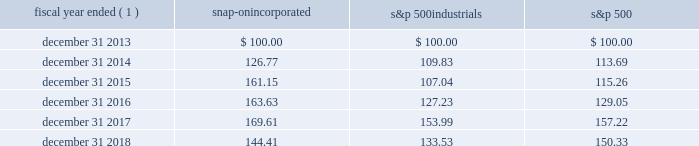2018 annual report 23 five-year stock performance graph the graph below illustrates the cumulative total shareholder return on snap-on common stock since december 31 , 2013 , of a $ 100 investment , assuming that dividends were reinvested quarterly .
The graph compares snap-on 2019s performance to that of the standard & poor 2019s 500 industrials index ( 201cs&p 500 industrials 201d ) and standard & poor 2019s 500 stock index ( 201cs&p 500 201d ) .
Fiscal year ended ( 1 ) snap-on incorporated s&p 500 industrials s&p 500 .
( 1 ) the company 2019s fiscal year ends on the saturday that is on or nearest to december 31 of each year ; for ease of calculation , the fiscal year end is assumed to be december 31. .
What is the average annual growth rate for snap from 2016 to 2018? 
Computations: ((((169.61 - 163.63) / 163.63) + (144.41 - 169.61)) / 2)
Answer: -12.58173. 